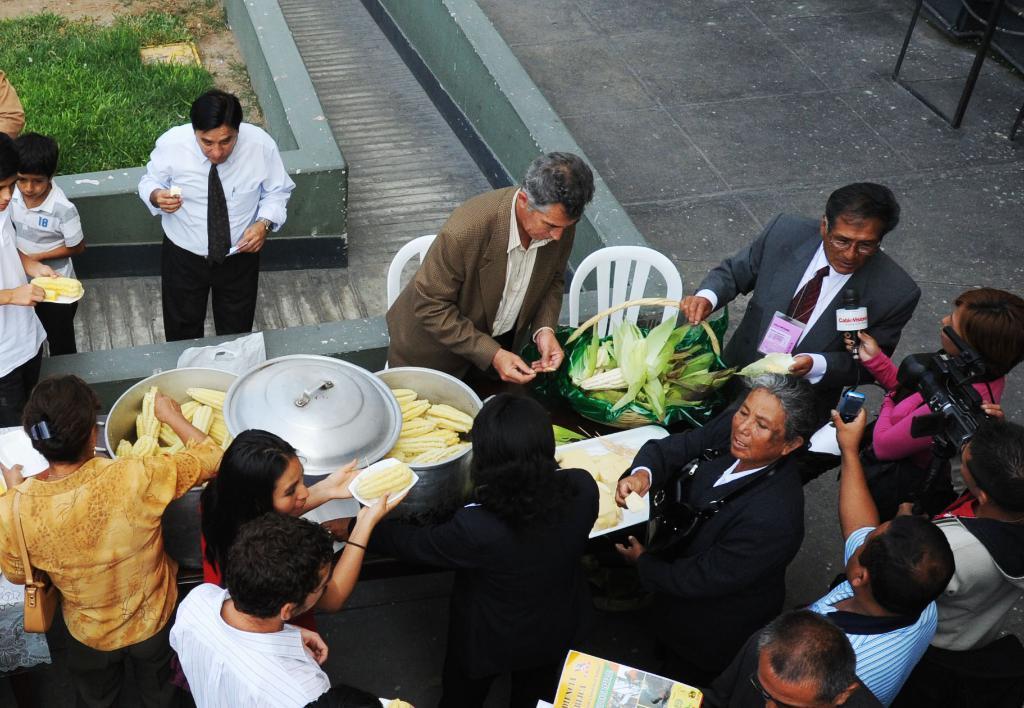In one or two sentences, can you explain what this image depicts? This picture describes about group of people, in front of them we can find food on the table, on the right side of the given image we can see a woman is holding microphone in her hand and a man is holding camera, in the background we can see grass and chairs. 